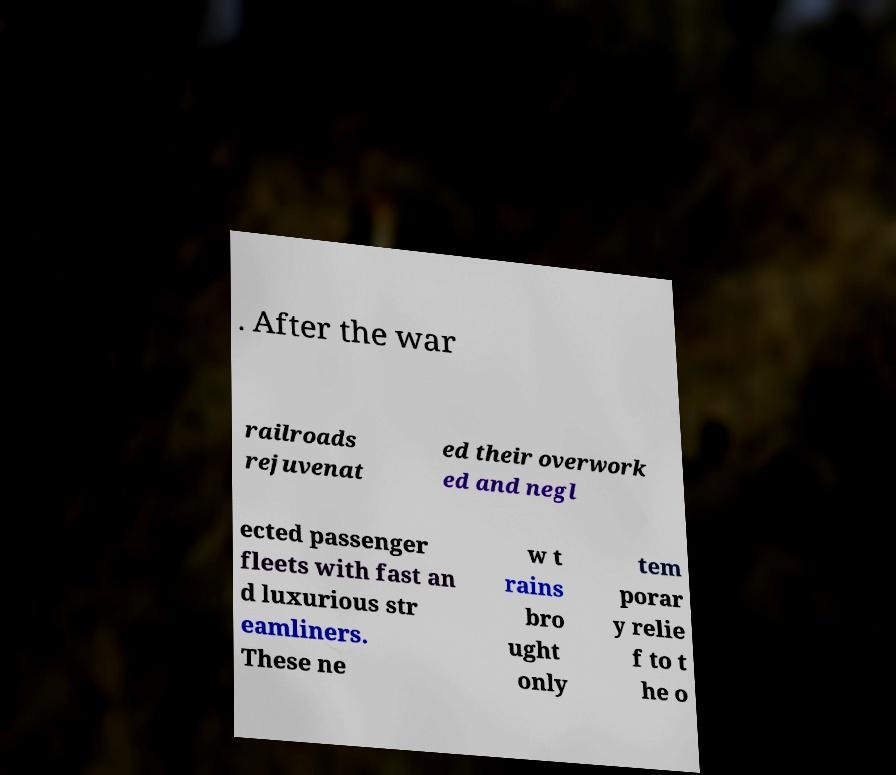What messages or text are displayed in this image? I need them in a readable, typed format. . After the war railroads rejuvenat ed their overwork ed and negl ected passenger fleets with fast an d luxurious str eamliners. These ne w t rains bro ught only tem porar y relie f to t he o 